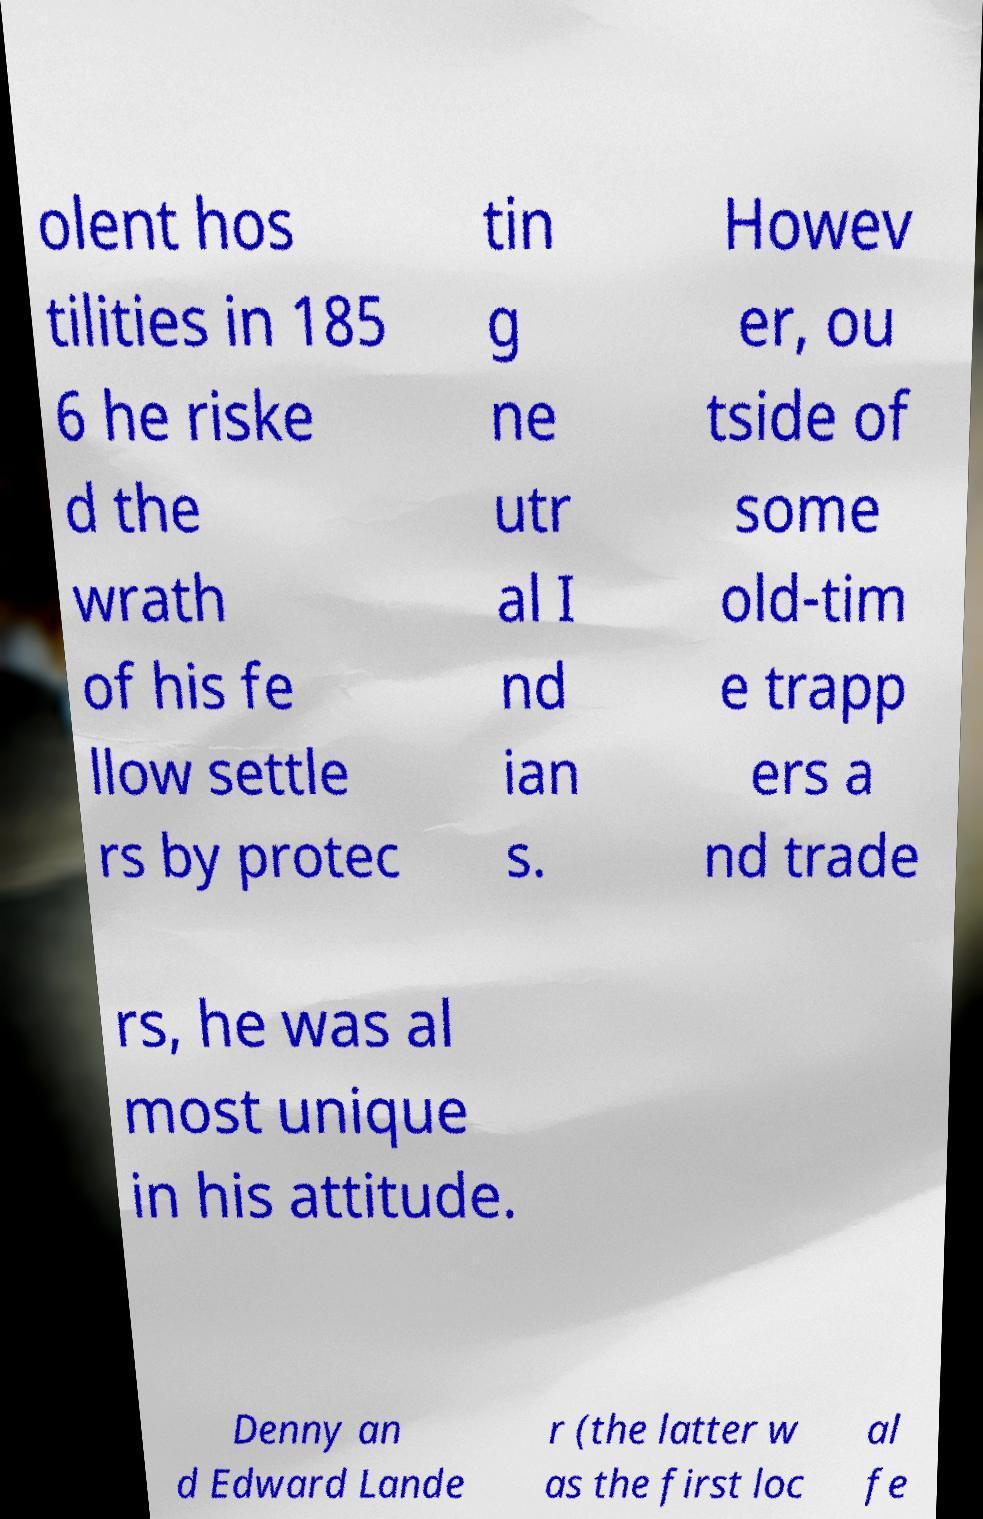For documentation purposes, I need the text within this image transcribed. Could you provide that? olent hos tilities in 185 6 he riske d the wrath of his fe llow settle rs by protec tin g ne utr al I nd ian s. Howev er, ou tside of some old-tim e trapp ers a nd trade rs, he was al most unique in his attitude. Denny an d Edward Lande r (the latter w as the first loc al fe 